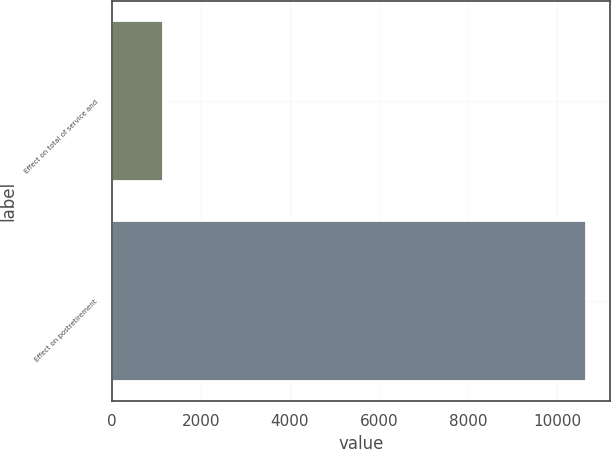Convert chart to OTSL. <chart><loc_0><loc_0><loc_500><loc_500><bar_chart><fcel>Effect on total of service and<fcel>Effect on postretirement<nl><fcel>1146<fcel>10653<nl></chart> 